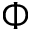Convert formula to latex. <formula><loc_0><loc_0><loc_500><loc_500>\Phi</formula> 